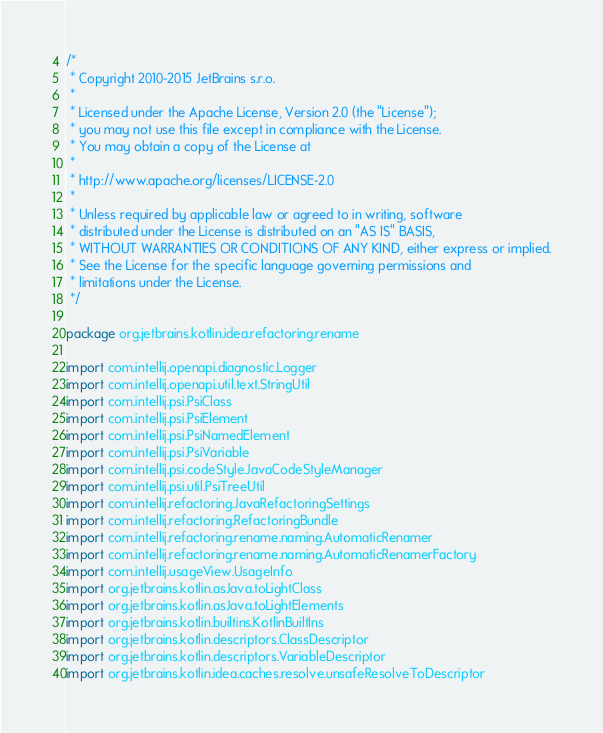<code> <loc_0><loc_0><loc_500><loc_500><_Kotlin_>/*
 * Copyright 2010-2015 JetBrains s.r.o.
 *
 * Licensed under the Apache License, Version 2.0 (the "License");
 * you may not use this file except in compliance with the License.
 * You may obtain a copy of the License at
 *
 * http://www.apache.org/licenses/LICENSE-2.0
 *
 * Unless required by applicable law or agreed to in writing, software
 * distributed under the License is distributed on an "AS IS" BASIS,
 * WITHOUT WARRANTIES OR CONDITIONS OF ANY KIND, either express or implied.
 * See the License for the specific language governing permissions and
 * limitations under the License.
 */

package org.jetbrains.kotlin.idea.refactoring.rename

import com.intellij.openapi.diagnostic.Logger
import com.intellij.openapi.util.text.StringUtil
import com.intellij.psi.PsiClass
import com.intellij.psi.PsiElement
import com.intellij.psi.PsiNamedElement
import com.intellij.psi.PsiVariable
import com.intellij.psi.codeStyle.JavaCodeStyleManager
import com.intellij.psi.util.PsiTreeUtil
import com.intellij.refactoring.JavaRefactoringSettings
import com.intellij.refactoring.RefactoringBundle
import com.intellij.refactoring.rename.naming.AutomaticRenamer
import com.intellij.refactoring.rename.naming.AutomaticRenamerFactory
import com.intellij.usageView.UsageInfo
import org.jetbrains.kotlin.asJava.toLightClass
import org.jetbrains.kotlin.asJava.toLightElements
import org.jetbrains.kotlin.builtins.KotlinBuiltIns
import org.jetbrains.kotlin.descriptors.ClassDescriptor
import org.jetbrains.kotlin.descriptors.VariableDescriptor
import org.jetbrains.kotlin.idea.caches.resolve.unsafeResolveToDescriptor</code> 